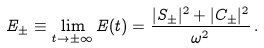Convert formula to latex. <formula><loc_0><loc_0><loc_500><loc_500>E _ { \pm } \equiv \lim _ { t \rightarrow \pm \infty } E ( t ) = \frac { | S _ { \pm } | ^ { 2 } + | C _ { \pm } | ^ { 2 } } { \omega ^ { 2 } } \, .</formula> 